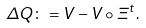Convert formula to latex. <formula><loc_0><loc_0><loc_500><loc_500>\Delta Q \colon = V - V \circ \Xi ^ { t } .</formula> 